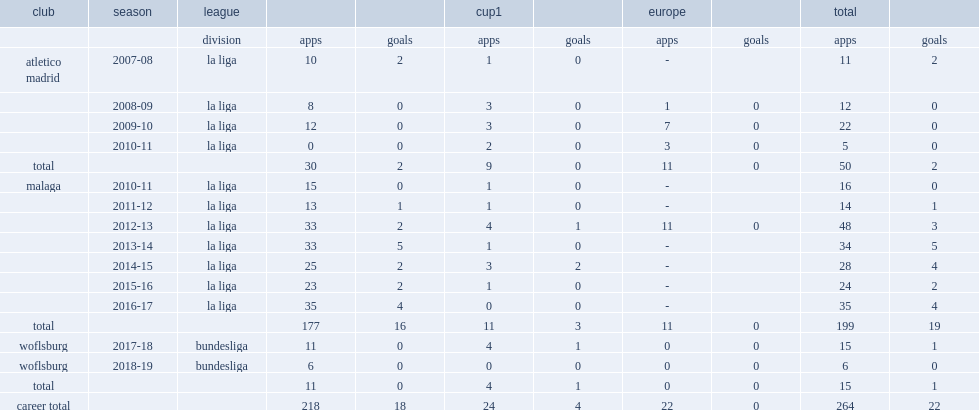How many matches did ignacio camacho play for malaga before joining wolfsburg? 199.0. 